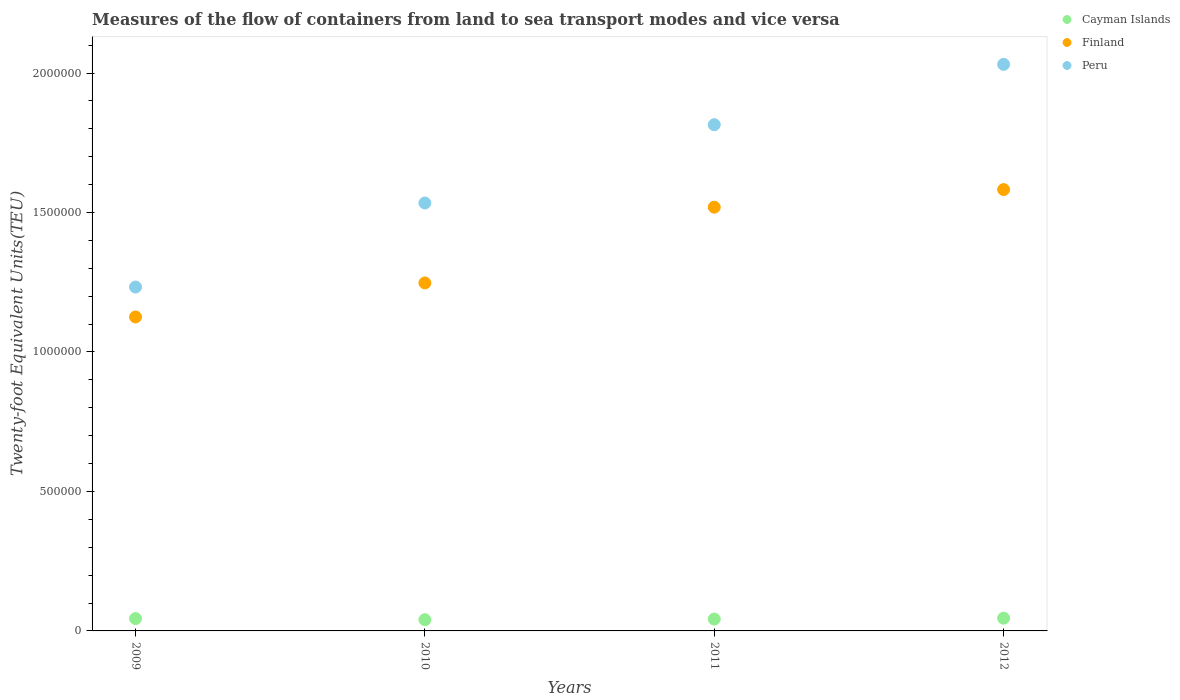What is the container port traffic in Finland in 2011?
Give a very brief answer. 1.52e+06. Across all years, what is the maximum container port traffic in Peru?
Your response must be concise. 2.03e+06. Across all years, what is the minimum container port traffic in Peru?
Make the answer very short. 1.23e+06. In which year was the container port traffic in Peru maximum?
Your response must be concise. 2012. What is the total container port traffic in Finland in the graph?
Make the answer very short. 5.47e+06. What is the difference between the container port traffic in Finland in 2009 and that in 2011?
Provide a succinct answer. -3.94e+05. What is the difference between the container port traffic in Finland in 2011 and the container port traffic in Peru in 2010?
Your answer should be compact. -1.49e+04. What is the average container port traffic in Peru per year?
Provide a succinct answer. 1.65e+06. In the year 2011, what is the difference between the container port traffic in Peru and container port traffic in Cayman Islands?
Ensure brevity in your answer.  1.77e+06. In how many years, is the container port traffic in Cayman Islands greater than 1100000 TEU?
Your answer should be compact. 0. What is the ratio of the container port traffic in Finland in 2010 to that in 2012?
Offer a terse response. 0.79. Is the container port traffic in Peru in 2010 less than that in 2011?
Your response must be concise. Yes. Is the difference between the container port traffic in Peru in 2009 and 2012 greater than the difference between the container port traffic in Cayman Islands in 2009 and 2012?
Your answer should be compact. No. What is the difference between the highest and the second highest container port traffic in Cayman Islands?
Offer a terse response. 1555.28. What is the difference between the highest and the lowest container port traffic in Peru?
Provide a short and direct response. 7.98e+05. Is the sum of the container port traffic in Peru in 2010 and 2012 greater than the maximum container port traffic in Finland across all years?
Provide a short and direct response. Yes. Is it the case that in every year, the sum of the container port traffic in Finland and container port traffic in Cayman Islands  is greater than the container port traffic in Peru?
Your answer should be compact. No. Does the container port traffic in Finland monotonically increase over the years?
Provide a succinct answer. Yes. Is the container port traffic in Finland strictly less than the container port traffic in Peru over the years?
Keep it short and to the point. Yes. How many dotlines are there?
Offer a very short reply. 3. How many years are there in the graph?
Make the answer very short. 4. What is the difference between two consecutive major ticks on the Y-axis?
Offer a very short reply. 5.00e+05. Are the values on the major ticks of Y-axis written in scientific E-notation?
Ensure brevity in your answer.  No. Does the graph contain grids?
Keep it short and to the point. No. Where does the legend appear in the graph?
Keep it short and to the point. Top right. How are the legend labels stacked?
Make the answer very short. Vertical. What is the title of the graph?
Provide a succinct answer. Measures of the flow of containers from land to sea transport modes and vice versa. What is the label or title of the X-axis?
Your answer should be very brief. Years. What is the label or title of the Y-axis?
Your response must be concise. Twenty-foot Equivalent Units(TEU). What is the Twenty-foot Equivalent Units(TEU) of Cayman Islands in 2009?
Your answer should be very brief. 4.42e+04. What is the Twenty-foot Equivalent Units(TEU) of Finland in 2009?
Make the answer very short. 1.13e+06. What is the Twenty-foot Equivalent Units(TEU) of Peru in 2009?
Provide a succinct answer. 1.23e+06. What is the Twenty-foot Equivalent Units(TEU) of Cayman Islands in 2010?
Provide a succinct answer. 4.03e+04. What is the Twenty-foot Equivalent Units(TEU) of Finland in 2010?
Your response must be concise. 1.25e+06. What is the Twenty-foot Equivalent Units(TEU) of Peru in 2010?
Offer a very short reply. 1.53e+06. What is the Twenty-foot Equivalent Units(TEU) in Cayman Islands in 2011?
Your answer should be very brief. 4.26e+04. What is the Twenty-foot Equivalent Units(TEU) in Finland in 2011?
Make the answer very short. 1.52e+06. What is the Twenty-foot Equivalent Units(TEU) of Peru in 2011?
Provide a succinct answer. 1.81e+06. What is the Twenty-foot Equivalent Units(TEU) of Cayman Islands in 2012?
Offer a very short reply. 4.58e+04. What is the Twenty-foot Equivalent Units(TEU) in Finland in 2012?
Provide a succinct answer. 1.58e+06. What is the Twenty-foot Equivalent Units(TEU) of Peru in 2012?
Your answer should be compact. 2.03e+06. Across all years, what is the maximum Twenty-foot Equivalent Units(TEU) of Cayman Islands?
Give a very brief answer. 4.58e+04. Across all years, what is the maximum Twenty-foot Equivalent Units(TEU) of Finland?
Offer a very short reply. 1.58e+06. Across all years, what is the maximum Twenty-foot Equivalent Units(TEU) in Peru?
Your answer should be compact. 2.03e+06. Across all years, what is the minimum Twenty-foot Equivalent Units(TEU) of Cayman Islands?
Keep it short and to the point. 4.03e+04. Across all years, what is the minimum Twenty-foot Equivalent Units(TEU) of Finland?
Ensure brevity in your answer.  1.13e+06. Across all years, what is the minimum Twenty-foot Equivalent Units(TEU) in Peru?
Give a very brief answer. 1.23e+06. What is the total Twenty-foot Equivalent Units(TEU) of Cayman Islands in the graph?
Your answer should be very brief. 1.73e+05. What is the total Twenty-foot Equivalent Units(TEU) in Finland in the graph?
Provide a short and direct response. 5.47e+06. What is the total Twenty-foot Equivalent Units(TEU) in Peru in the graph?
Make the answer very short. 6.61e+06. What is the difference between the Twenty-foot Equivalent Units(TEU) of Cayman Islands in 2009 and that in 2010?
Give a very brief answer. 3934. What is the difference between the Twenty-foot Equivalent Units(TEU) of Finland in 2009 and that in 2010?
Provide a succinct answer. -1.22e+05. What is the difference between the Twenty-foot Equivalent Units(TEU) in Peru in 2009 and that in 2010?
Provide a succinct answer. -3.01e+05. What is the difference between the Twenty-foot Equivalent Units(TEU) in Cayman Islands in 2009 and that in 2011?
Ensure brevity in your answer.  1638. What is the difference between the Twenty-foot Equivalent Units(TEU) in Finland in 2009 and that in 2011?
Your answer should be very brief. -3.94e+05. What is the difference between the Twenty-foot Equivalent Units(TEU) of Peru in 2009 and that in 2011?
Offer a terse response. -5.82e+05. What is the difference between the Twenty-foot Equivalent Units(TEU) in Cayman Islands in 2009 and that in 2012?
Provide a succinct answer. -1555.28. What is the difference between the Twenty-foot Equivalent Units(TEU) in Finland in 2009 and that in 2012?
Ensure brevity in your answer.  -4.57e+05. What is the difference between the Twenty-foot Equivalent Units(TEU) in Peru in 2009 and that in 2012?
Ensure brevity in your answer.  -7.98e+05. What is the difference between the Twenty-foot Equivalent Units(TEU) of Cayman Islands in 2010 and that in 2011?
Give a very brief answer. -2296. What is the difference between the Twenty-foot Equivalent Units(TEU) in Finland in 2010 and that in 2011?
Make the answer very short. -2.72e+05. What is the difference between the Twenty-foot Equivalent Units(TEU) of Peru in 2010 and that in 2011?
Provide a succinct answer. -2.81e+05. What is the difference between the Twenty-foot Equivalent Units(TEU) of Cayman Islands in 2010 and that in 2012?
Ensure brevity in your answer.  -5489.27. What is the difference between the Twenty-foot Equivalent Units(TEU) in Finland in 2010 and that in 2012?
Make the answer very short. -3.35e+05. What is the difference between the Twenty-foot Equivalent Units(TEU) of Peru in 2010 and that in 2012?
Keep it short and to the point. -4.97e+05. What is the difference between the Twenty-foot Equivalent Units(TEU) of Cayman Islands in 2011 and that in 2012?
Provide a succinct answer. -3193.28. What is the difference between the Twenty-foot Equivalent Units(TEU) in Finland in 2011 and that in 2012?
Give a very brief answer. -6.31e+04. What is the difference between the Twenty-foot Equivalent Units(TEU) of Peru in 2011 and that in 2012?
Your response must be concise. -2.16e+05. What is the difference between the Twenty-foot Equivalent Units(TEU) of Cayman Islands in 2009 and the Twenty-foot Equivalent Units(TEU) of Finland in 2010?
Your answer should be very brief. -1.20e+06. What is the difference between the Twenty-foot Equivalent Units(TEU) in Cayman Islands in 2009 and the Twenty-foot Equivalent Units(TEU) in Peru in 2010?
Keep it short and to the point. -1.49e+06. What is the difference between the Twenty-foot Equivalent Units(TEU) of Finland in 2009 and the Twenty-foot Equivalent Units(TEU) of Peru in 2010?
Your response must be concise. -4.09e+05. What is the difference between the Twenty-foot Equivalent Units(TEU) in Cayman Islands in 2009 and the Twenty-foot Equivalent Units(TEU) in Finland in 2011?
Make the answer very short. -1.47e+06. What is the difference between the Twenty-foot Equivalent Units(TEU) in Cayman Islands in 2009 and the Twenty-foot Equivalent Units(TEU) in Peru in 2011?
Keep it short and to the point. -1.77e+06. What is the difference between the Twenty-foot Equivalent Units(TEU) in Finland in 2009 and the Twenty-foot Equivalent Units(TEU) in Peru in 2011?
Ensure brevity in your answer.  -6.89e+05. What is the difference between the Twenty-foot Equivalent Units(TEU) in Cayman Islands in 2009 and the Twenty-foot Equivalent Units(TEU) in Finland in 2012?
Give a very brief answer. -1.54e+06. What is the difference between the Twenty-foot Equivalent Units(TEU) in Cayman Islands in 2009 and the Twenty-foot Equivalent Units(TEU) in Peru in 2012?
Provide a succinct answer. -1.99e+06. What is the difference between the Twenty-foot Equivalent Units(TEU) of Finland in 2009 and the Twenty-foot Equivalent Units(TEU) of Peru in 2012?
Your answer should be very brief. -9.06e+05. What is the difference between the Twenty-foot Equivalent Units(TEU) in Cayman Islands in 2010 and the Twenty-foot Equivalent Units(TEU) in Finland in 2011?
Your answer should be very brief. -1.48e+06. What is the difference between the Twenty-foot Equivalent Units(TEU) in Cayman Islands in 2010 and the Twenty-foot Equivalent Units(TEU) in Peru in 2011?
Your answer should be very brief. -1.77e+06. What is the difference between the Twenty-foot Equivalent Units(TEU) in Finland in 2010 and the Twenty-foot Equivalent Units(TEU) in Peru in 2011?
Give a very brief answer. -5.67e+05. What is the difference between the Twenty-foot Equivalent Units(TEU) in Cayman Islands in 2010 and the Twenty-foot Equivalent Units(TEU) in Finland in 2012?
Provide a succinct answer. -1.54e+06. What is the difference between the Twenty-foot Equivalent Units(TEU) of Cayman Islands in 2010 and the Twenty-foot Equivalent Units(TEU) of Peru in 2012?
Provide a short and direct response. -1.99e+06. What is the difference between the Twenty-foot Equivalent Units(TEU) of Finland in 2010 and the Twenty-foot Equivalent Units(TEU) of Peru in 2012?
Make the answer very short. -7.84e+05. What is the difference between the Twenty-foot Equivalent Units(TEU) of Cayman Islands in 2011 and the Twenty-foot Equivalent Units(TEU) of Finland in 2012?
Provide a short and direct response. -1.54e+06. What is the difference between the Twenty-foot Equivalent Units(TEU) in Cayman Islands in 2011 and the Twenty-foot Equivalent Units(TEU) in Peru in 2012?
Make the answer very short. -1.99e+06. What is the difference between the Twenty-foot Equivalent Units(TEU) of Finland in 2011 and the Twenty-foot Equivalent Units(TEU) of Peru in 2012?
Give a very brief answer. -5.12e+05. What is the average Twenty-foot Equivalent Units(TEU) in Cayman Islands per year?
Your answer should be compact. 4.32e+04. What is the average Twenty-foot Equivalent Units(TEU) of Finland per year?
Make the answer very short. 1.37e+06. What is the average Twenty-foot Equivalent Units(TEU) in Peru per year?
Your answer should be compact. 1.65e+06. In the year 2009, what is the difference between the Twenty-foot Equivalent Units(TEU) in Cayman Islands and Twenty-foot Equivalent Units(TEU) in Finland?
Keep it short and to the point. -1.08e+06. In the year 2009, what is the difference between the Twenty-foot Equivalent Units(TEU) in Cayman Islands and Twenty-foot Equivalent Units(TEU) in Peru?
Make the answer very short. -1.19e+06. In the year 2009, what is the difference between the Twenty-foot Equivalent Units(TEU) in Finland and Twenty-foot Equivalent Units(TEU) in Peru?
Give a very brief answer. -1.07e+05. In the year 2010, what is the difference between the Twenty-foot Equivalent Units(TEU) in Cayman Islands and Twenty-foot Equivalent Units(TEU) in Finland?
Keep it short and to the point. -1.21e+06. In the year 2010, what is the difference between the Twenty-foot Equivalent Units(TEU) of Cayman Islands and Twenty-foot Equivalent Units(TEU) of Peru?
Provide a short and direct response. -1.49e+06. In the year 2010, what is the difference between the Twenty-foot Equivalent Units(TEU) of Finland and Twenty-foot Equivalent Units(TEU) of Peru?
Keep it short and to the point. -2.87e+05. In the year 2011, what is the difference between the Twenty-foot Equivalent Units(TEU) in Cayman Islands and Twenty-foot Equivalent Units(TEU) in Finland?
Your answer should be very brief. -1.48e+06. In the year 2011, what is the difference between the Twenty-foot Equivalent Units(TEU) of Cayman Islands and Twenty-foot Equivalent Units(TEU) of Peru?
Offer a very short reply. -1.77e+06. In the year 2011, what is the difference between the Twenty-foot Equivalent Units(TEU) in Finland and Twenty-foot Equivalent Units(TEU) in Peru?
Keep it short and to the point. -2.96e+05. In the year 2012, what is the difference between the Twenty-foot Equivalent Units(TEU) of Cayman Islands and Twenty-foot Equivalent Units(TEU) of Finland?
Your answer should be very brief. -1.54e+06. In the year 2012, what is the difference between the Twenty-foot Equivalent Units(TEU) of Cayman Islands and Twenty-foot Equivalent Units(TEU) of Peru?
Your answer should be very brief. -1.99e+06. In the year 2012, what is the difference between the Twenty-foot Equivalent Units(TEU) in Finland and Twenty-foot Equivalent Units(TEU) in Peru?
Your response must be concise. -4.49e+05. What is the ratio of the Twenty-foot Equivalent Units(TEU) of Cayman Islands in 2009 to that in 2010?
Provide a short and direct response. 1.1. What is the ratio of the Twenty-foot Equivalent Units(TEU) of Finland in 2009 to that in 2010?
Offer a very short reply. 0.9. What is the ratio of the Twenty-foot Equivalent Units(TEU) of Peru in 2009 to that in 2010?
Provide a succinct answer. 0.8. What is the ratio of the Twenty-foot Equivalent Units(TEU) in Cayman Islands in 2009 to that in 2011?
Keep it short and to the point. 1.04. What is the ratio of the Twenty-foot Equivalent Units(TEU) in Finland in 2009 to that in 2011?
Provide a short and direct response. 0.74. What is the ratio of the Twenty-foot Equivalent Units(TEU) of Peru in 2009 to that in 2011?
Give a very brief answer. 0.68. What is the ratio of the Twenty-foot Equivalent Units(TEU) in Finland in 2009 to that in 2012?
Your answer should be compact. 0.71. What is the ratio of the Twenty-foot Equivalent Units(TEU) in Peru in 2009 to that in 2012?
Offer a very short reply. 0.61. What is the ratio of the Twenty-foot Equivalent Units(TEU) in Cayman Islands in 2010 to that in 2011?
Offer a very short reply. 0.95. What is the ratio of the Twenty-foot Equivalent Units(TEU) in Finland in 2010 to that in 2011?
Offer a very short reply. 0.82. What is the ratio of the Twenty-foot Equivalent Units(TEU) in Peru in 2010 to that in 2011?
Your response must be concise. 0.85. What is the ratio of the Twenty-foot Equivalent Units(TEU) in Cayman Islands in 2010 to that in 2012?
Provide a short and direct response. 0.88. What is the ratio of the Twenty-foot Equivalent Units(TEU) in Finland in 2010 to that in 2012?
Make the answer very short. 0.79. What is the ratio of the Twenty-foot Equivalent Units(TEU) in Peru in 2010 to that in 2012?
Give a very brief answer. 0.76. What is the ratio of the Twenty-foot Equivalent Units(TEU) in Cayman Islands in 2011 to that in 2012?
Offer a terse response. 0.93. What is the ratio of the Twenty-foot Equivalent Units(TEU) of Finland in 2011 to that in 2012?
Ensure brevity in your answer.  0.96. What is the ratio of the Twenty-foot Equivalent Units(TEU) of Peru in 2011 to that in 2012?
Make the answer very short. 0.89. What is the difference between the highest and the second highest Twenty-foot Equivalent Units(TEU) in Cayman Islands?
Your answer should be very brief. 1555.28. What is the difference between the highest and the second highest Twenty-foot Equivalent Units(TEU) of Finland?
Your answer should be compact. 6.31e+04. What is the difference between the highest and the second highest Twenty-foot Equivalent Units(TEU) in Peru?
Your answer should be very brief. 2.16e+05. What is the difference between the highest and the lowest Twenty-foot Equivalent Units(TEU) in Cayman Islands?
Your answer should be compact. 5489.27. What is the difference between the highest and the lowest Twenty-foot Equivalent Units(TEU) in Finland?
Provide a succinct answer. 4.57e+05. What is the difference between the highest and the lowest Twenty-foot Equivalent Units(TEU) of Peru?
Your answer should be very brief. 7.98e+05. 